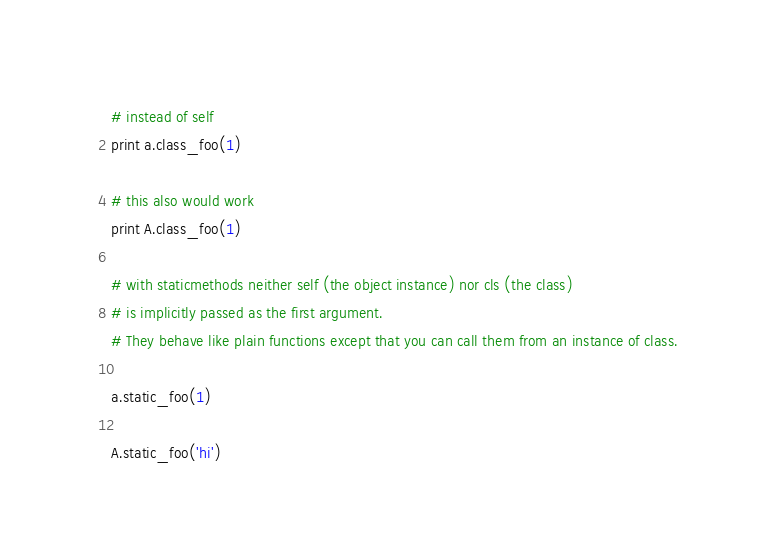<code> <loc_0><loc_0><loc_500><loc_500><_Python_># instead of self
print a.class_foo(1)

# this also would work
print A.class_foo(1)

# with staticmethods neither self (the object instance) nor cls (the class)
# is implicitly passed as the first argument.
# They behave like plain functions except that you can call them from an instance of class.

a.static_foo(1)

A.static_foo('hi')
</code> 